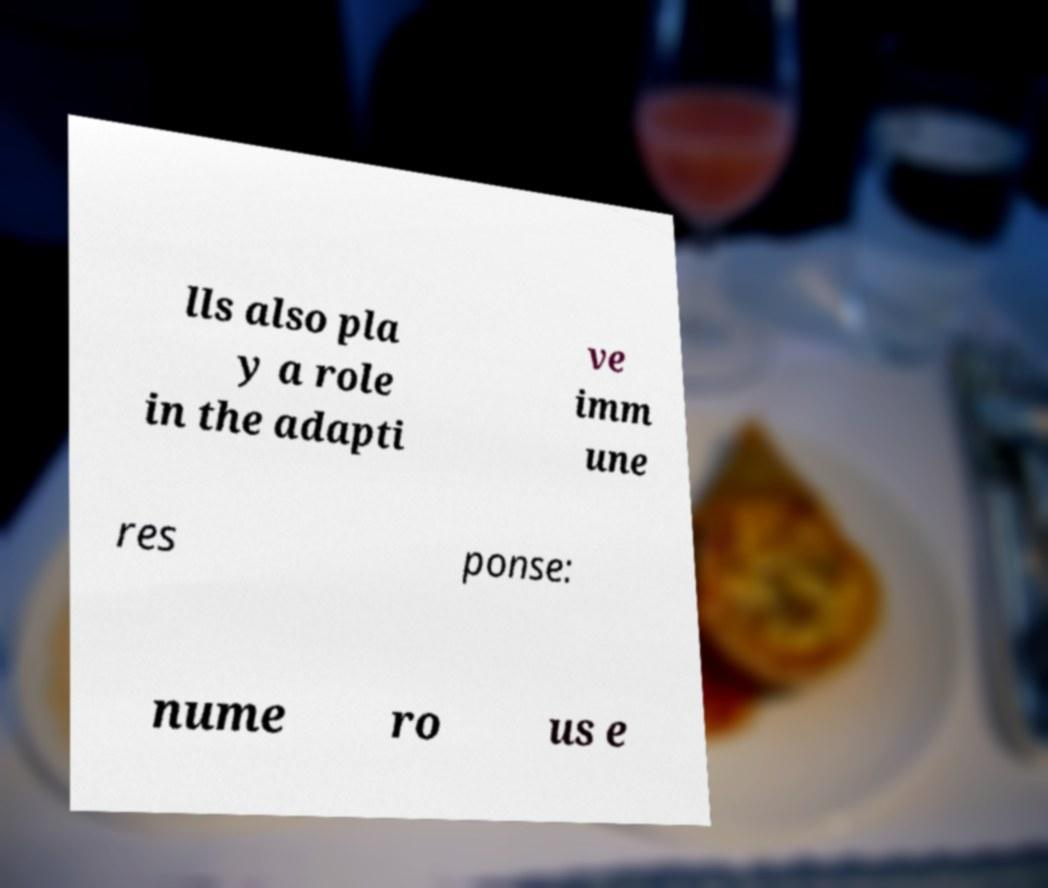Could you assist in decoding the text presented in this image and type it out clearly? lls also pla y a role in the adapti ve imm une res ponse: nume ro us e 